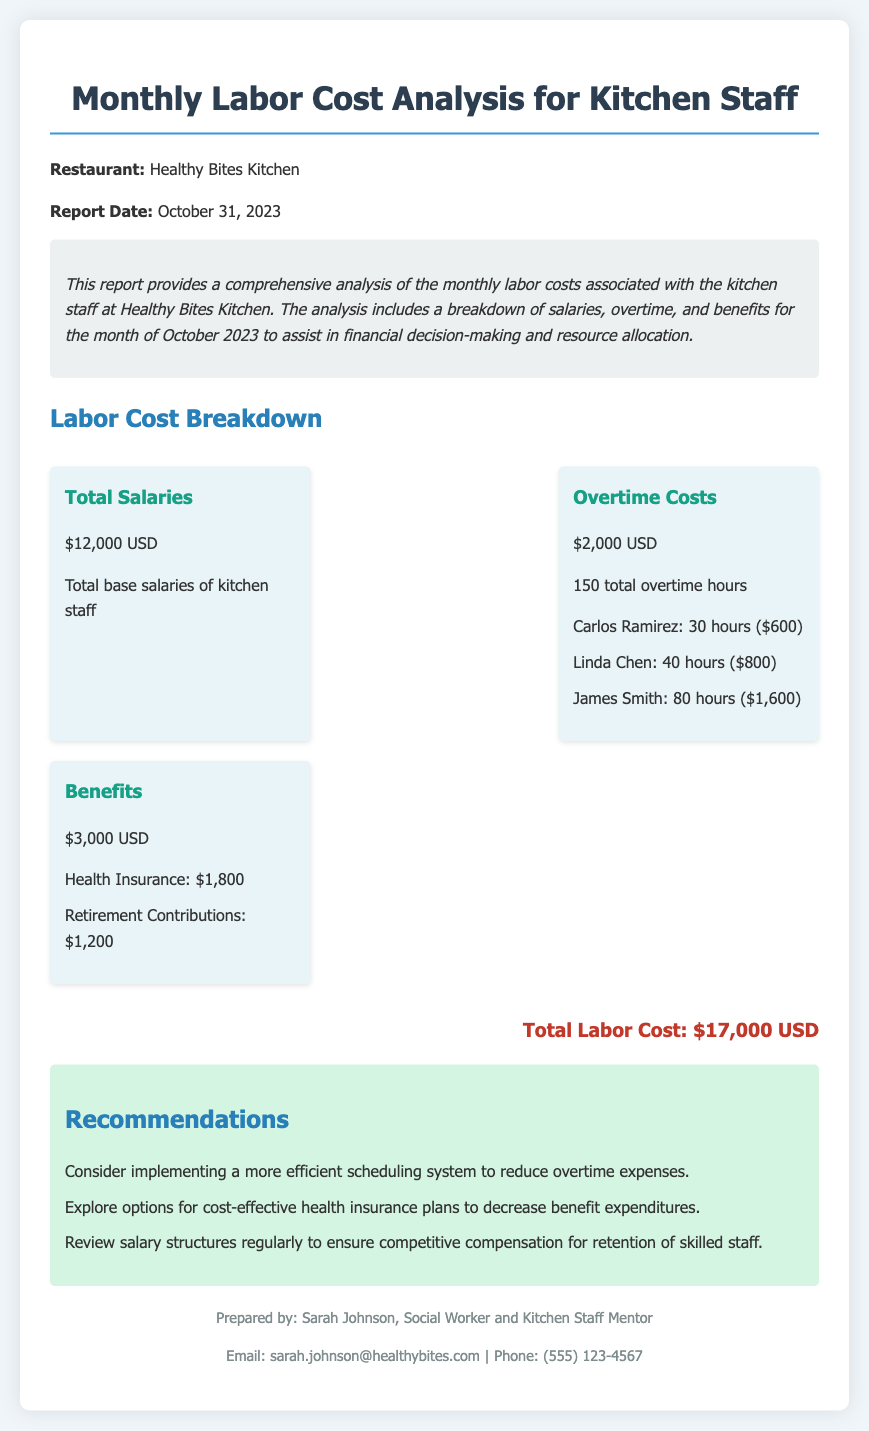What is the total labor cost? The total labor cost is stated at the bottom of the report as the sum of all costs associated with kitchen staff.
Answer: $17,000 USD What is the report date? The report date is provided at the beginning of the document as the date this analysis was prepared.
Answer: October 31, 2023 How much was spent on benefits? The benefits section lists the total expenditures for benefits, which includes health insurance and retirement contributions.
Answer: $3,000 USD Who worked the most overtime hours? The overtime section outlines the hours worked by each staff member, and James Smith has the highest total.
Answer: James Smith What is the cost of health insurance? In the benefits section, the cost allocated for health insurance is explicitly stated.
Answer: $1,800 How many total overtime hours were recorded? The total overtime hours are summarized in the overtime costs section of the document.
Answer: 150 hours What recommendation is made regarding scheduling? The recommendations section provides suggestions to optimize costs, and one involves scheduling practices.
Answer: Implement a more efficient scheduling system How much were total salaries? The salaries of kitchen staff are summarized in a specific section of the document, detailing the total amount spent.
Answer: $12,000 USD 